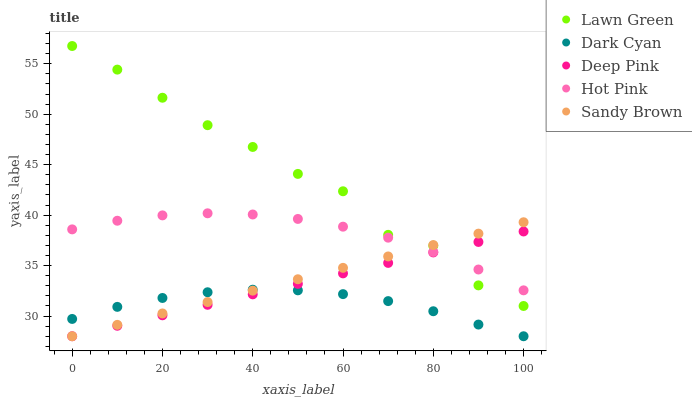Does Dark Cyan have the minimum area under the curve?
Answer yes or no. Yes. Does Lawn Green have the maximum area under the curve?
Answer yes or no. Yes. Does Deep Pink have the minimum area under the curve?
Answer yes or no. No. Does Deep Pink have the maximum area under the curve?
Answer yes or no. No. Is Deep Pink the smoothest?
Answer yes or no. Yes. Is Lawn Green the roughest?
Answer yes or no. Yes. Is Lawn Green the smoothest?
Answer yes or no. No. Is Deep Pink the roughest?
Answer yes or no. No. Does Dark Cyan have the lowest value?
Answer yes or no. Yes. Does Lawn Green have the lowest value?
Answer yes or no. No. Does Lawn Green have the highest value?
Answer yes or no. Yes. Does Deep Pink have the highest value?
Answer yes or no. No. Is Dark Cyan less than Hot Pink?
Answer yes or no. Yes. Is Hot Pink greater than Dark Cyan?
Answer yes or no. Yes. Does Dark Cyan intersect Sandy Brown?
Answer yes or no. Yes. Is Dark Cyan less than Sandy Brown?
Answer yes or no. No. Is Dark Cyan greater than Sandy Brown?
Answer yes or no. No. Does Dark Cyan intersect Hot Pink?
Answer yes or no. No. 